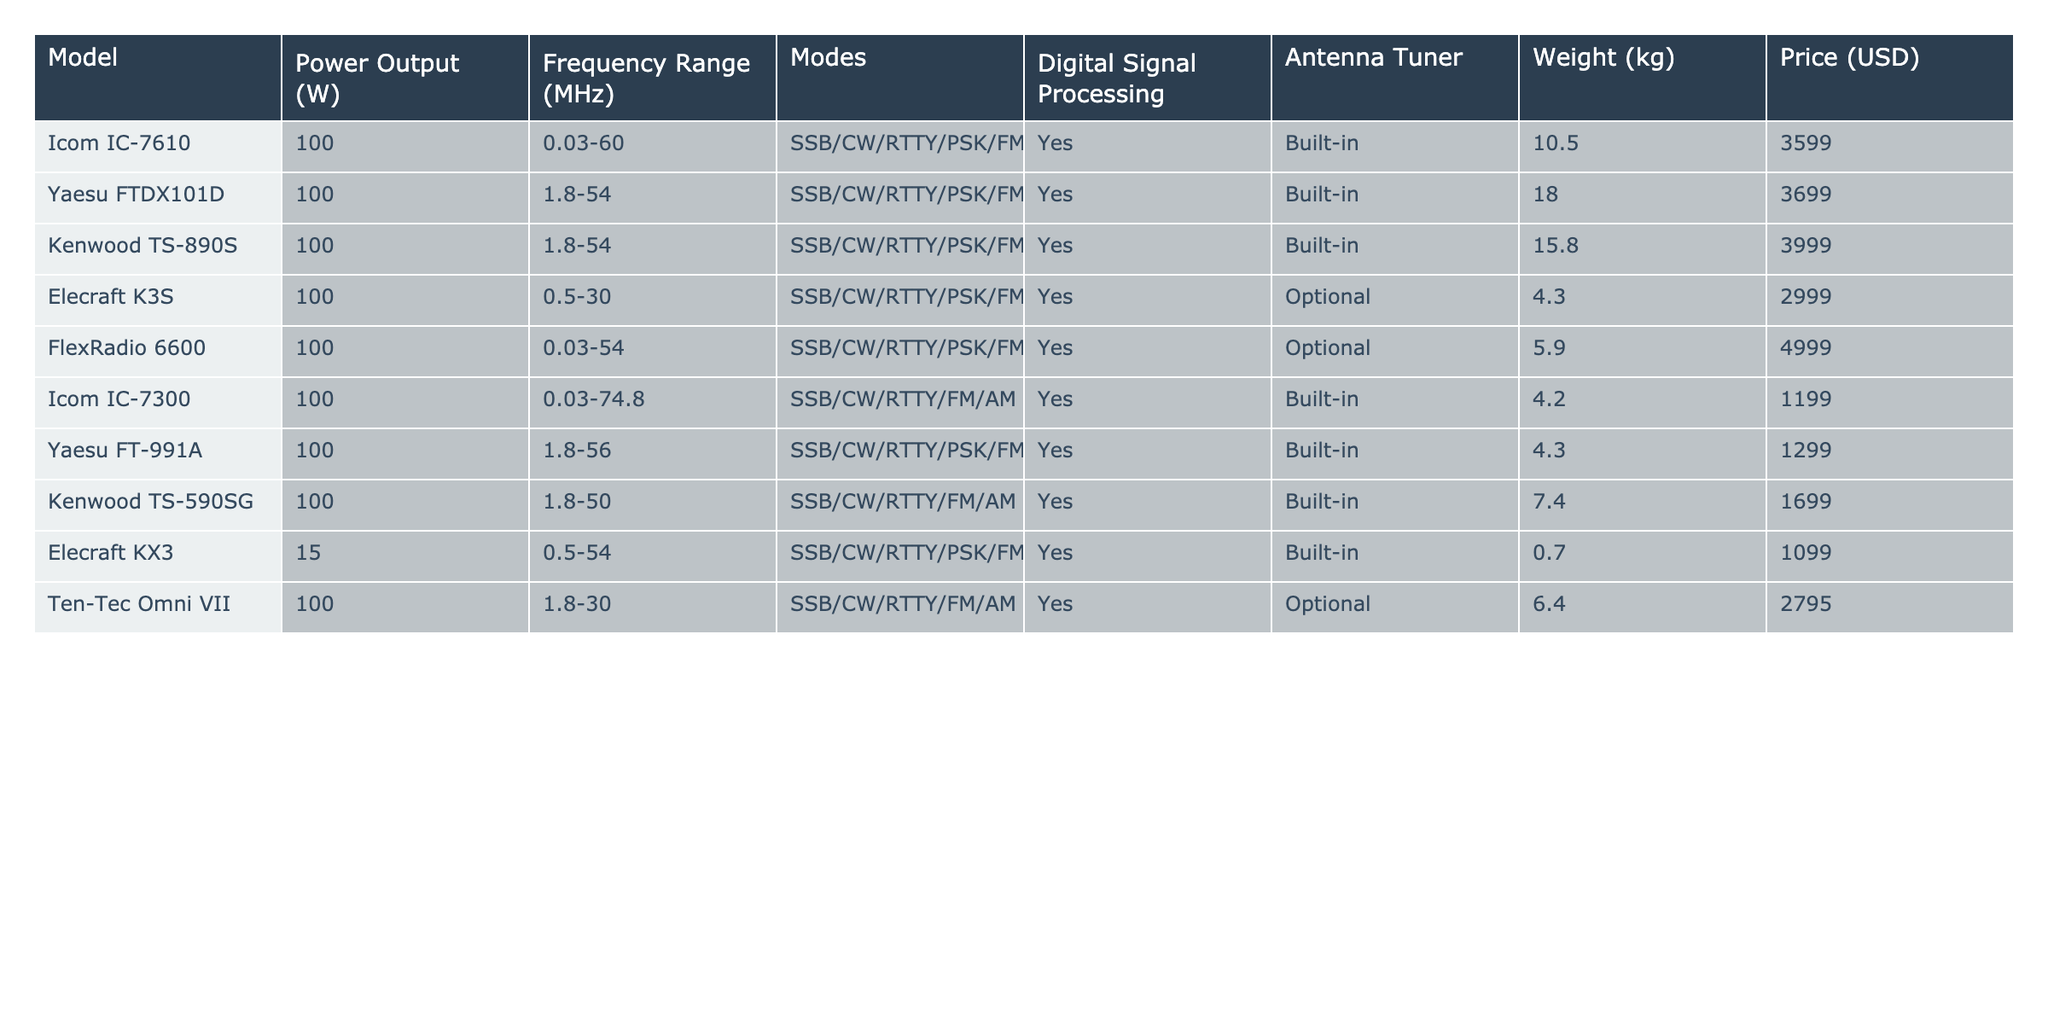What is the power output of the Icom IC-7610? The table shows the specifications for the Icom IC-7610, where the power output is listed as 100 W.
Answer: 100 W Does the Elecraft K3S come with a built-in antenna tuner? According to the table, the Elecraft K3S has an optional antenna tuner, indicating it does not come with a built-in one.
Answer: No What is the weight difference between the Kenwood TS-890S and the Icom IC-7300? The weight of the Kenwood TS-890S is 15.8 kg and the Icom IC-7300 is 4.2 kg. The difference is calculated as 15.8 - 4.2 = 11.6 kg.
Answer: 11.6 kg Which model has the widest frequency range? By examining the frequency range column, the FlexRadio 6600 has a range of 0.03-54 MHz, which is the widest range listed among the options.
Answer: FlexRadio 6600 What is the average price of all listed transceivers? To calculate the average, sum the prices (3599 + 3699 + 3999 + 2999 + 4999 + 1199 + 1299 + 1699 + 1099 + 2795 = 19884) and divide by the number of models (10), resulting in 1988.4.
Answer: 1988.4 USD Is there any model that weighs less than 1 kg? The table shows the Elecraft KX3 weighs 0.7 kg, which is indeed less than 1 kg.
Answer: Yes How many models have a built-in digital signal processing feature? The table indicates that all listed models, ten in total, have built-in digital signal processing, affirmatively counting each entry.
Answer: 10 Which models have optional antenna tuners? From the table, it can be seen that the Elecraft K3S and FlexRadio 6600 are the only models listed with an optional antenna tuner.
Answer: Elecraft K3S, FlexRadio 6600 What is the total power output of the Elecraft KX3 and Icom IC-7300 combined? The power output for the Elecraft KX3 is 15 W and for the Icom IC-7300 it is 100 W, thus the total power output is 15 + 100 = 115 W.
Answer: 115 W Find the model with the lowest price and confirm if it weighs less than 5 kg. The lowest price in the table is for the Icom IC-7300 at 1199 USD, and it weighs 4.2 kg, which is indeed less than 5 kg.
Answer: Yes 